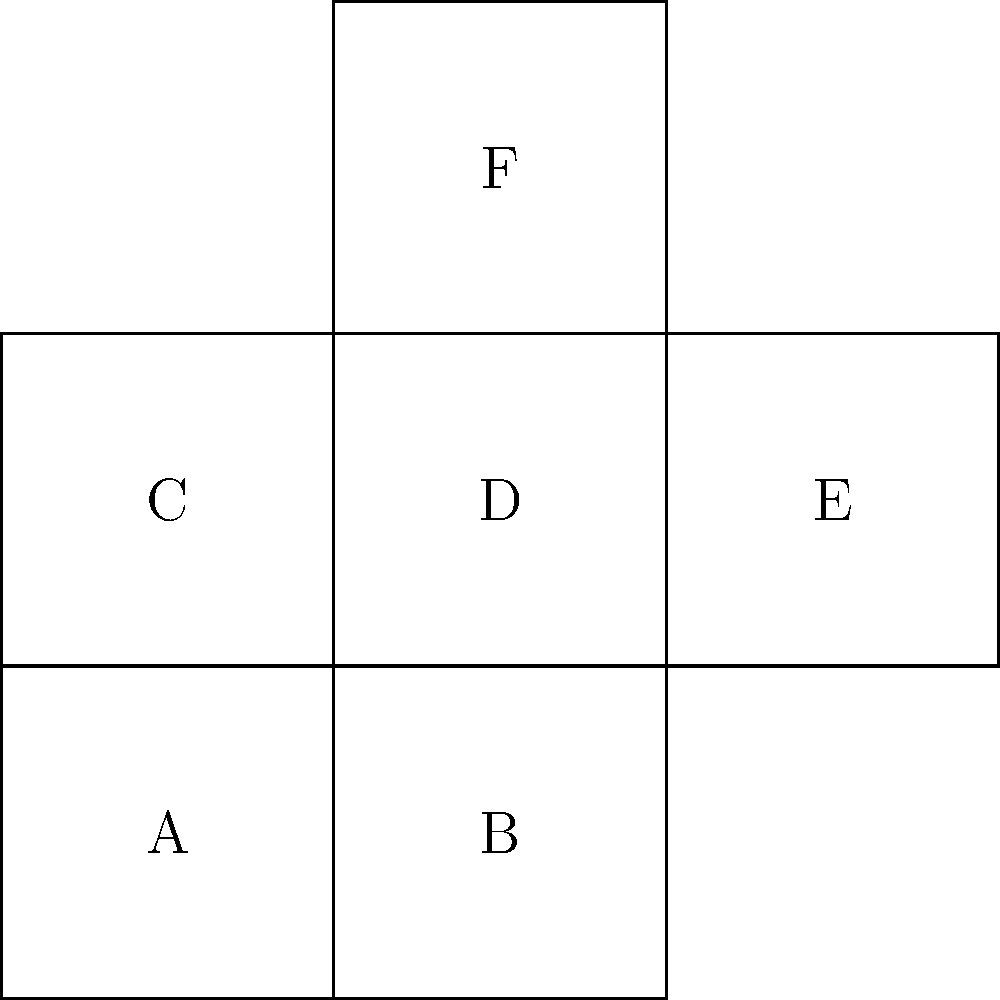As part of a rehabilitation activity for recovering alcoholics, you're designing a spatial reasoning exercise. The image shows a 2D net on the left and a 3D cube on the right. If the net is folded to form a cube, which face will be opposite to face A? To determine which face will be opposite to face A when the net is folded into a cube, let's follow these steps:

1. Identify face A on the net (bottom-left square).

2. Visualize the folding process:
   - Face B folds up to form the right side of the cube.
   - Face C folds up to form the back of the cube.
   - Face D remains as the top face of the cube.
   - Face E folds to form the left side of the cube.
   - Face F folds down to form the front of the cube.

3. After folding, face A becomes the bottom face of the cube.

4. In a cube, opposite faces are those that do not share any edges.

5. Examining the net, we can see that face F does not share any edges with face A.

6. When folded, face F will be on the opposite side of the cube from face A.

Therefore, face F will be opposite to face A when the net is folded into a cube.
Answer: F 